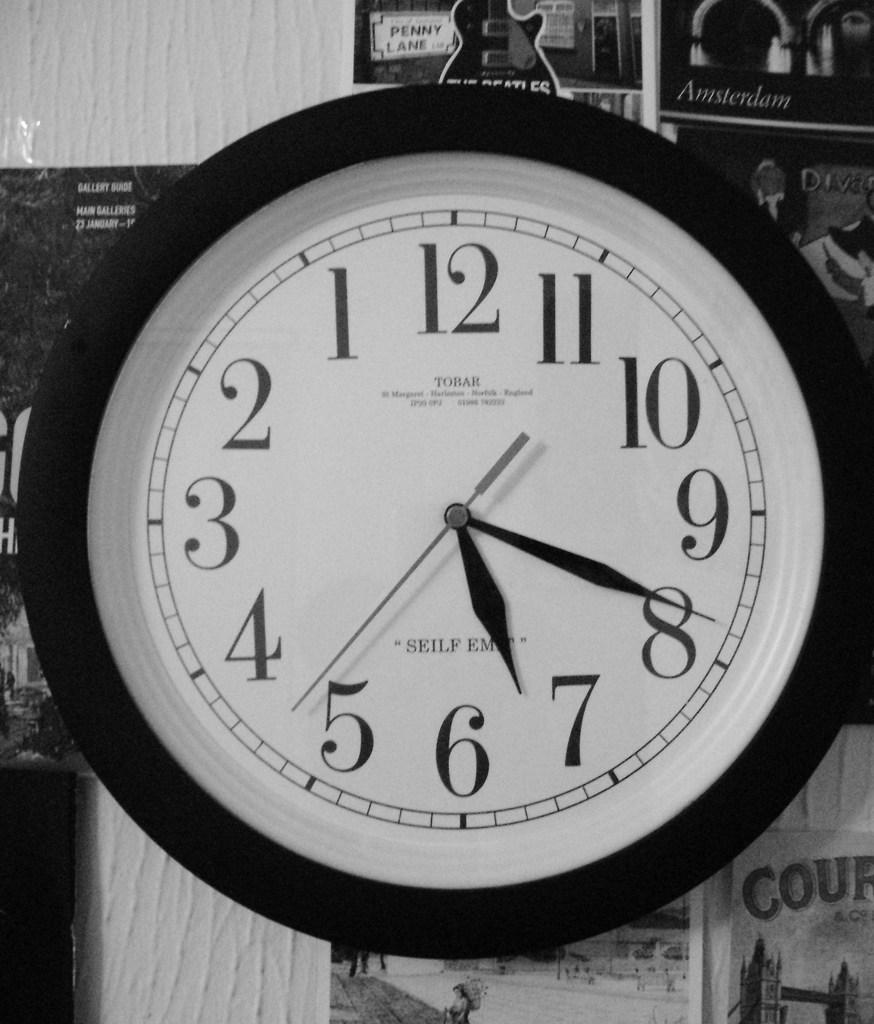<image>
Give a short and clear explanation of the subsequent image. A Tobar brand clock showing that it is 7:19. 